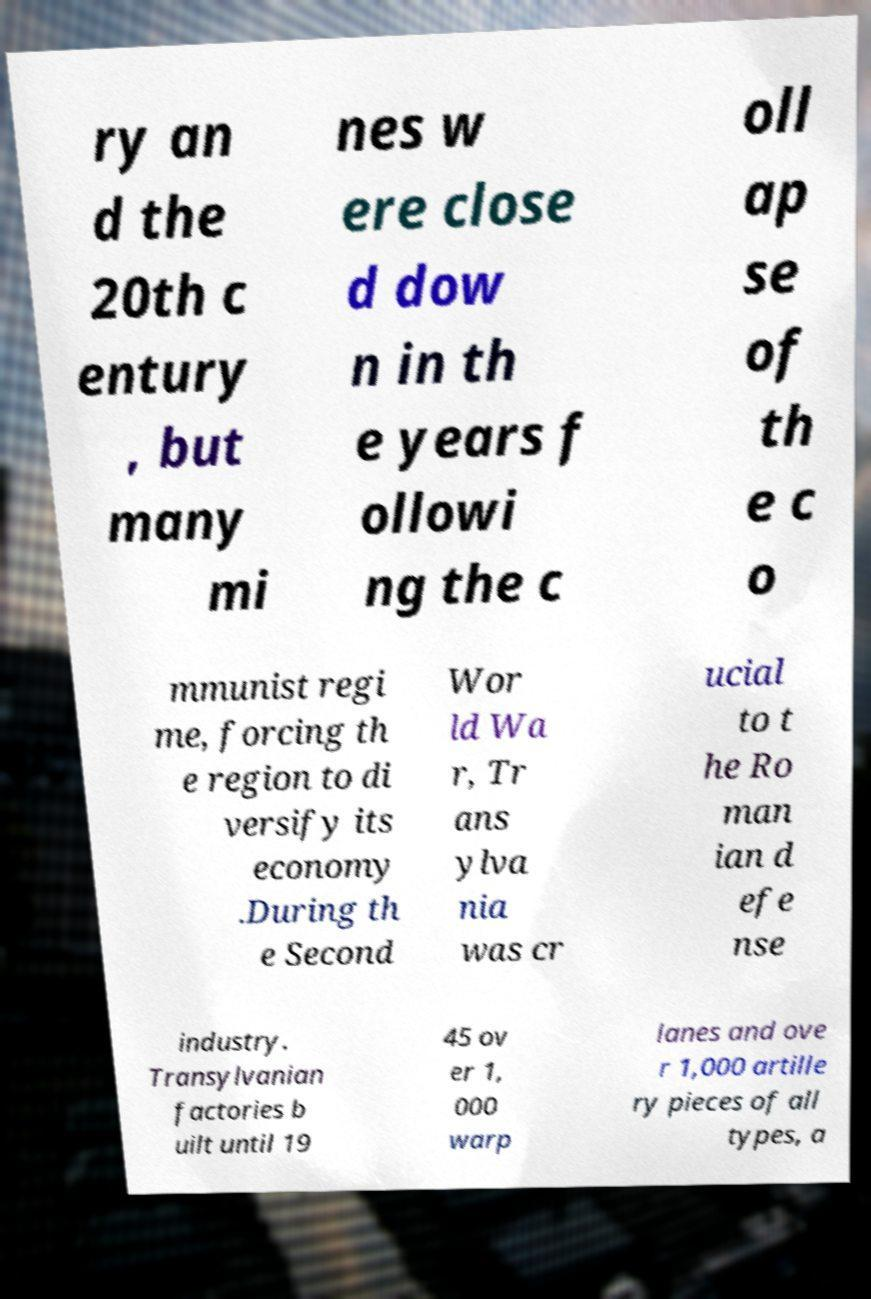Could you assist in decoding the text presented in this image and type it out clearly? ry an d the 20th c entury , but many mi nes w ere close d dow n in th e years f ollowi ng the c oll ap se of th e c o mmunist regi me, forcing th e region to di versify its economy .During th e Second Wor ld Wa r, Tr ans ylva nia was cr ucial to t he Ro man ian d efe nse industry. Transylvanian factories b uilt until 19 45 ov er 1, 000 warp lanes and ove r 1,000 artille ry pieces of all types, a 